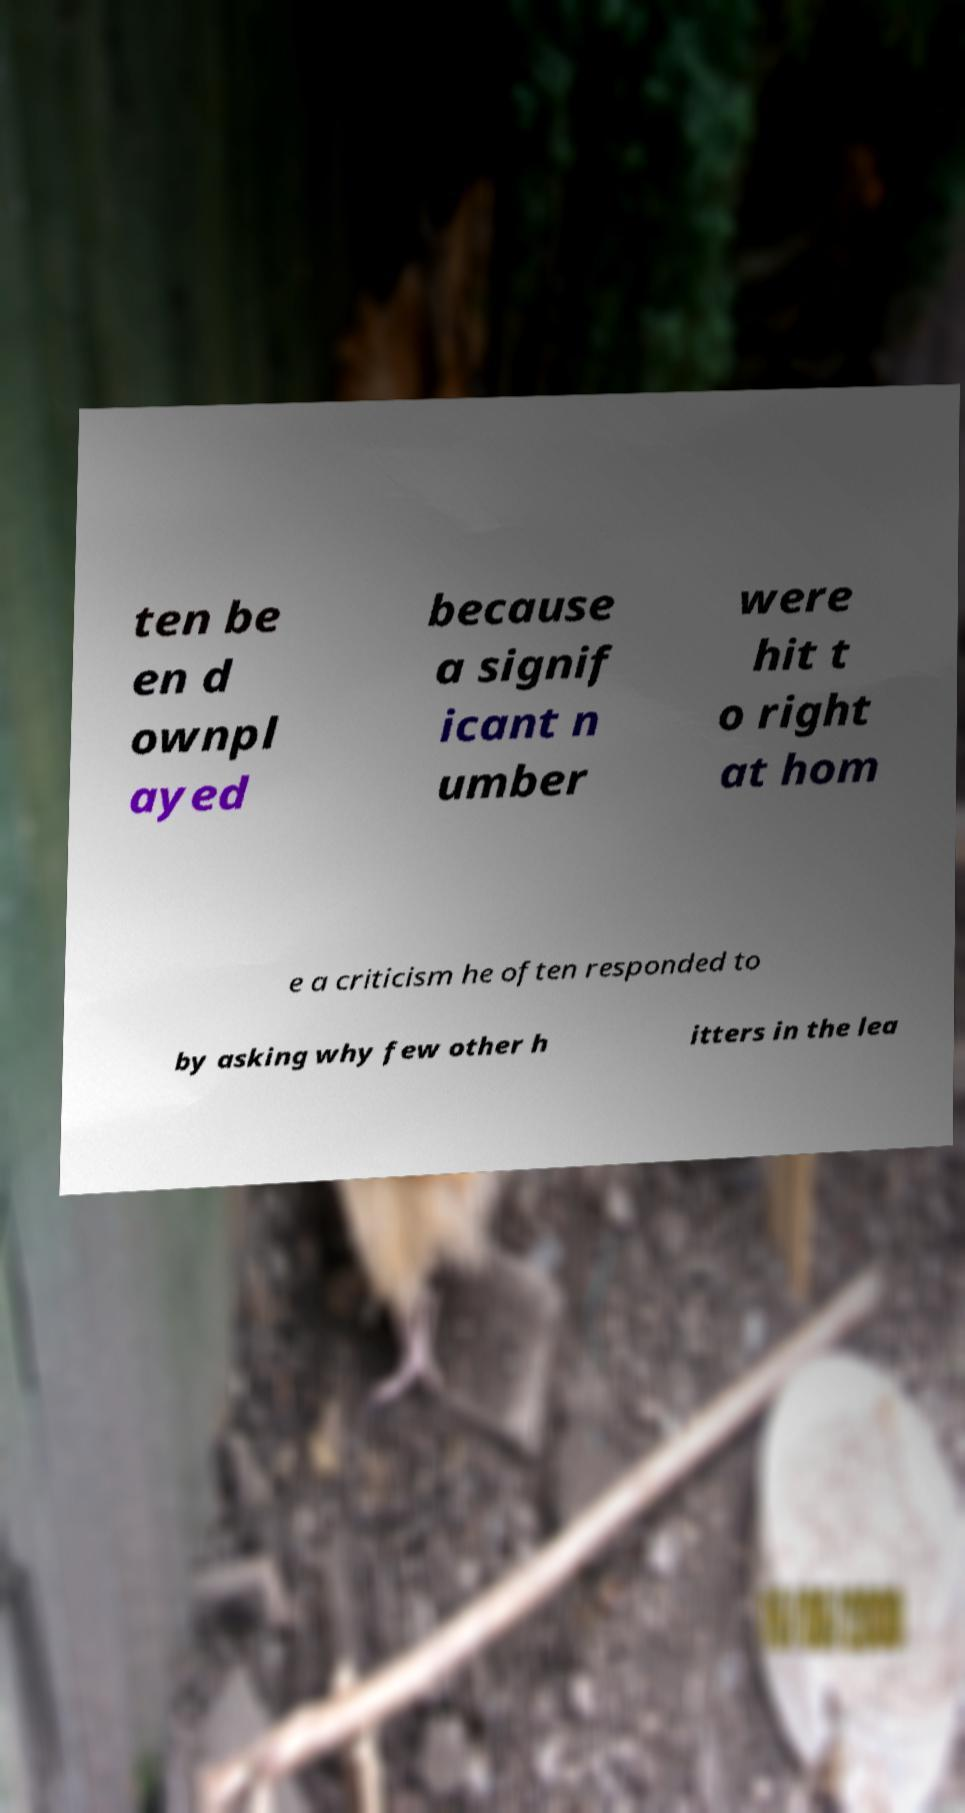Please identify and transcribe the text found in this image. ten be en d ownpl ayed because a signif icant n umber were hit t o right at hom e a criticism he often responded to by asking why few other h itters in the lea 